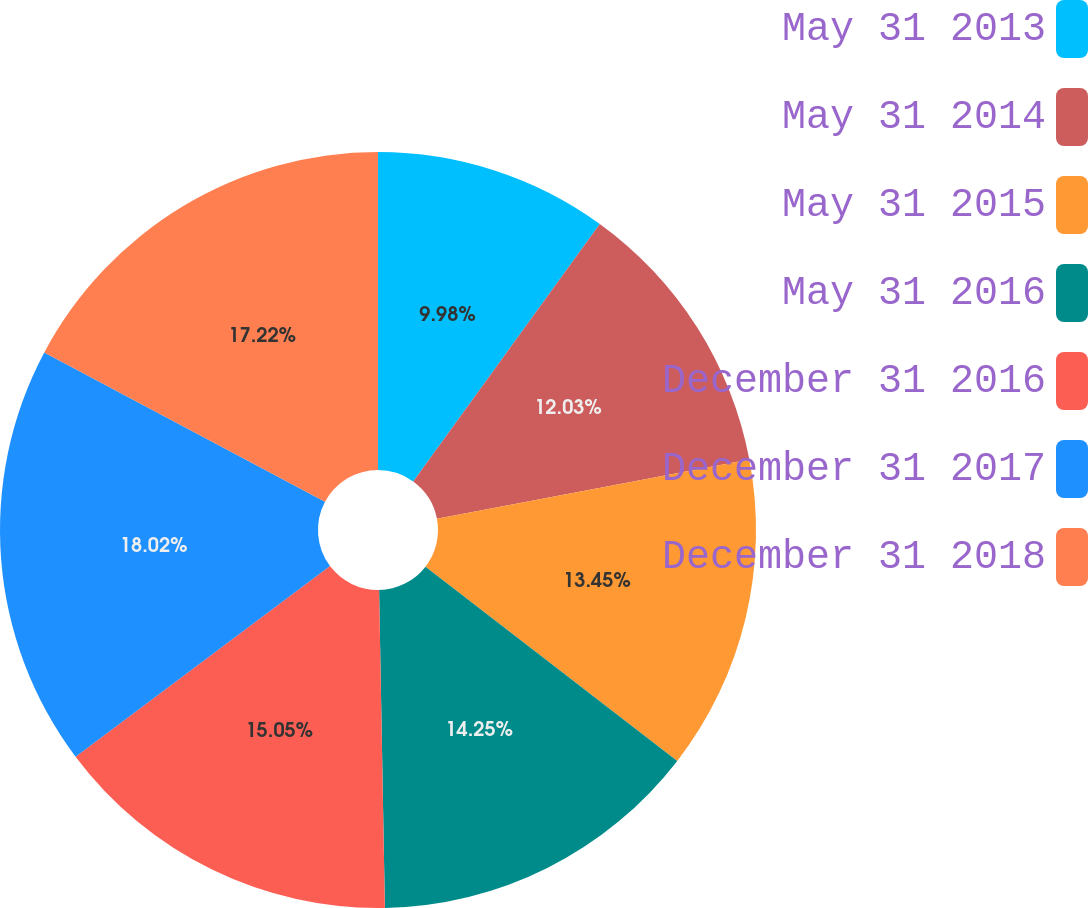<chart> <loc_0><loc_0><loc_500><loc_500><pie_chart><fcel>May 31 2013<fcel>May 31 2014<fcel>May 31 2015<fcel>May 31 2016<fcel>December 31 2016<fcel>December 31 2017<fcel>December 31 2018<nl><fcel>9.98%<fcel>12.03%<fcel>13.45%<fcel>14.25%<fcel>15.05%<fcel>18.02%<fcel>17.22%<nl></chart> 